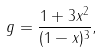Convert formula to latex. <formula><loc_0><loc_0><loc_500><loc_500>g = \frac { 1 + 3 x ^ { 2 } } { ( 1 - x ) ^ { 3 } } ,</formula> 